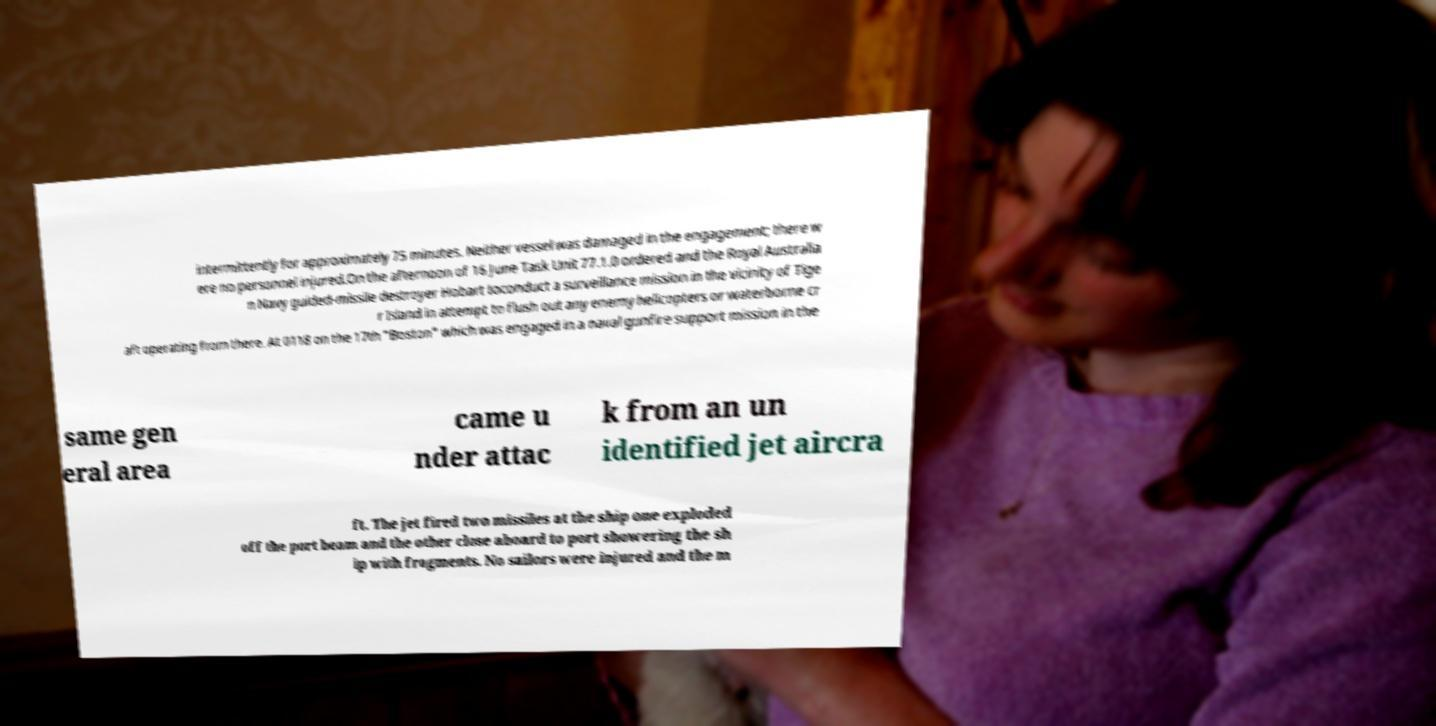Could you assist in decoding the text presented in this image and type it out clearly? intermittently for approximately 75 minutes. Neither vessel was damaged in the engagement; there w ere no personnel injured.On the afternoon of 16 June Task Unit 77.1.0 ordered and the Royal Australia n Navy guided-missile destroyer Hobart toconduct a surveillance mission in the vicinity of Tige r Island in attempt to flush out any enemy helicopters or waterborne cr aft operating from there. At 0118 on the 17th "Boston" which was engaged in a naval gunfire support mission in the same gen eral area came u nder attac k from an un identified jet aircra ft. The jet fired two missiles at the ship one exploded off the port beam and the other close aboard to port showering the sh ip with fragments. No sailors were injured and the m 